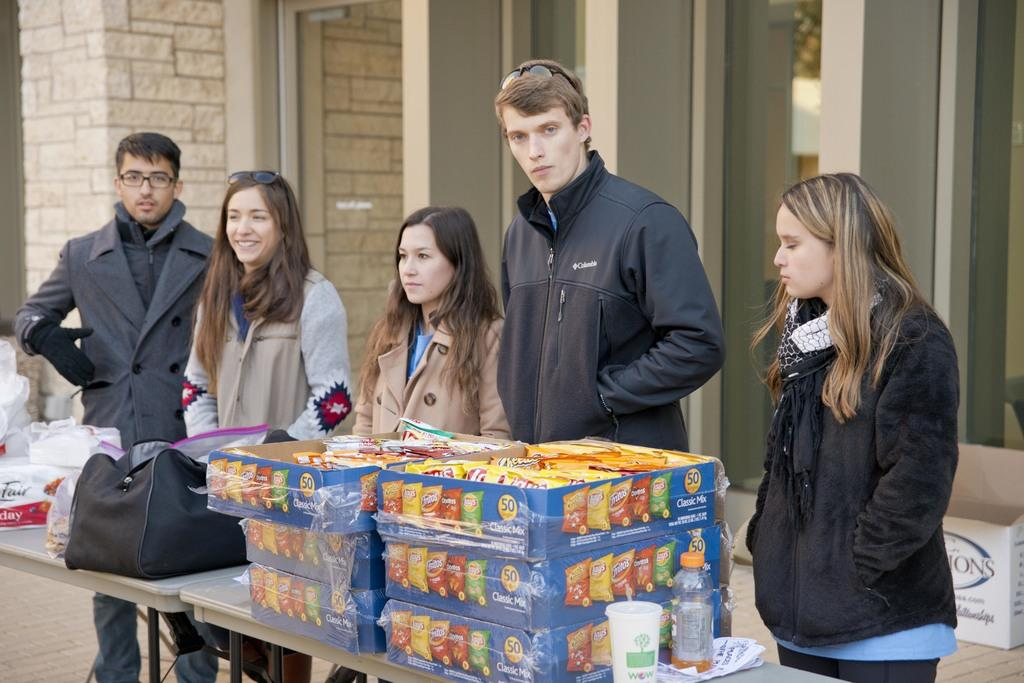What type of structures can be seen in the image? There are buildings in the image. Are there any people present in the image? Yes, there are people standing in the image. What object can be found on the table in the image? There is a box on the table in the image. What is placed on the table along with the box? There is a table in the image, and on it, there are glasses and a black color bag. What else can be found on the table? There are also boxes on the table. What type of canvas is being used by the people in the image? There is no canvas present in the image. What is the ground made of in the image? The ground is not visible in the image, so it cannot be determined what it is made of. 